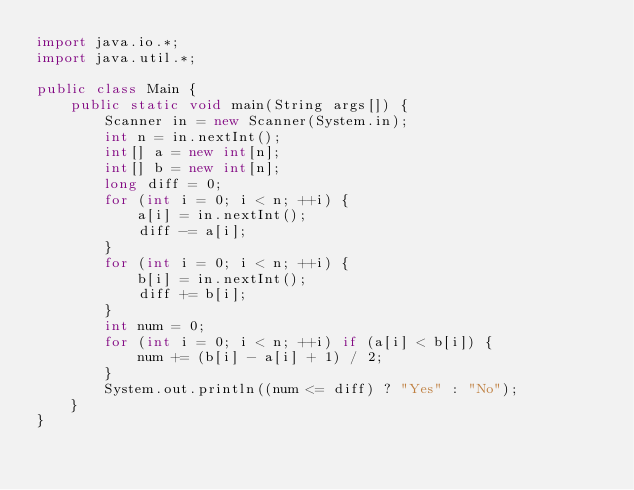<code> <loc_0><loc_0><loc_500><loc_500><_Java_>import java.io.*;
import java.util.*;

public class Main {
    public static void main(String args[]) {
        Scanner in = new Scanner(System.in);
        int n = in.nextInt();
        int[] a = new int[n];
        int[] b = new int[n];
        long diff = 0;
        for (int i = 0; i < n; ++i) {
            a[i] = in.nextInt();
            diff -= a[i];
        }
        for (int i = 0; i < n; ++i) {
            b[i] = in.nextInt();
            diff += b[i];
        }
        int num = 0;
        for (int i = 0; i < n; ++i) if (a[i] < b[i]) {
            num += (b[i] - a[i] + 1) / 2;
        }
        System.out.println((num <= diff) ? "Yes" : "No");
    }
}</code> 